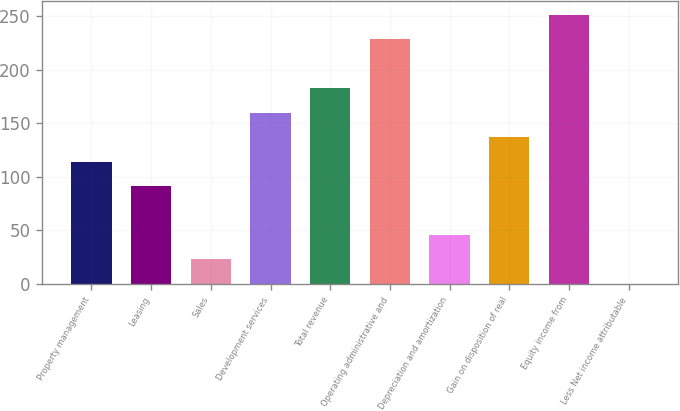Convert chart. <chart><loc_0><loc_0><loc_500><loc_500><bar_chart><fcel>Property management<fcel>Leasing<fcel>Sales<fcel>Development services<fcel>Total revenue<fcel>Operating administrative and<fcel>Depreciation and amortization<fcel>Gain on disposition of real<fcel>Equity income from<fcel>Less Net income attributable<nl><fcel>114.35<fcel>91.52<fcel>23.03<fcel>160.01<fcel>182.84<fcel>228.5<fcel>45.86<fcel>137.18<fcel>251.33<fcel>0.2<nl></chart> 